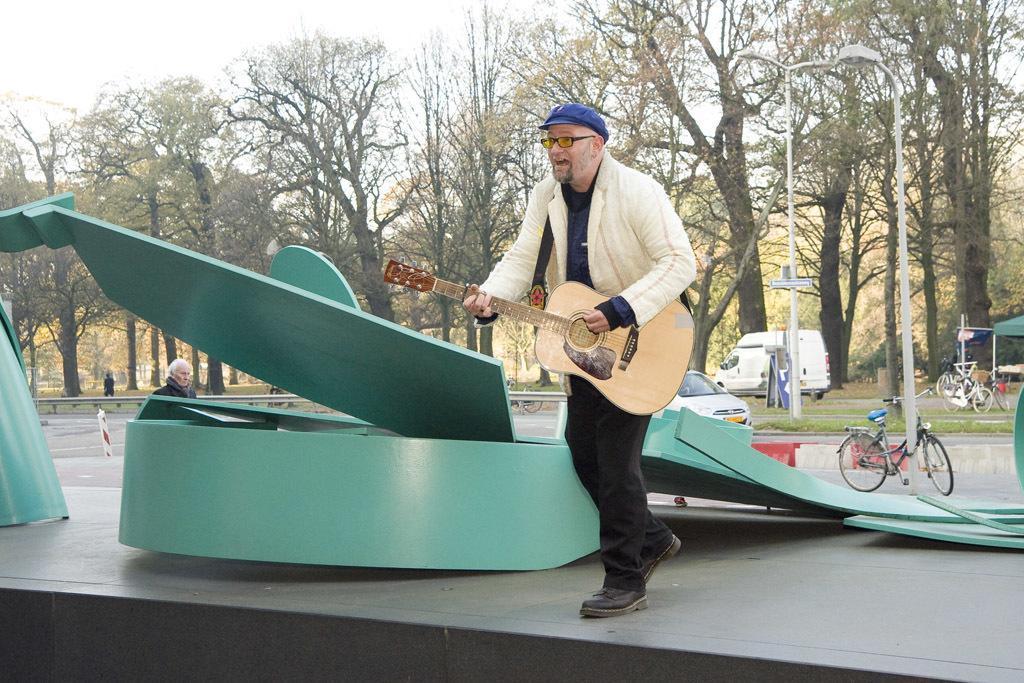Please provide a concise description of this image. The image is taken in the open area ,a man is standing on the stage and playing a guitar is also wearing spectacles behind him, there is green color ride, beside that there is another old man standing behind this person who is playing guitar there is a car ,cycle, a van, in the background there are many trees and sky. 